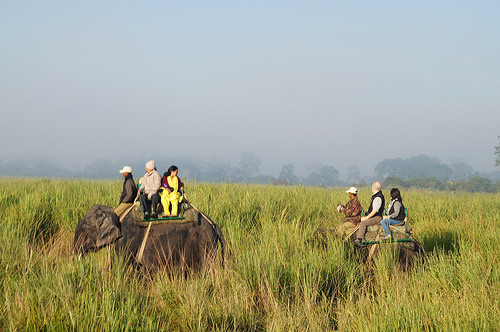<image>
Is there a person in the grass? No. The person is not contained within the grass. These objects have a different spatial relationship. Is there a elephant in front of the girl? No. The elephant is not in front of the girl. The spatial positioning shows a different relationship between these objects. 